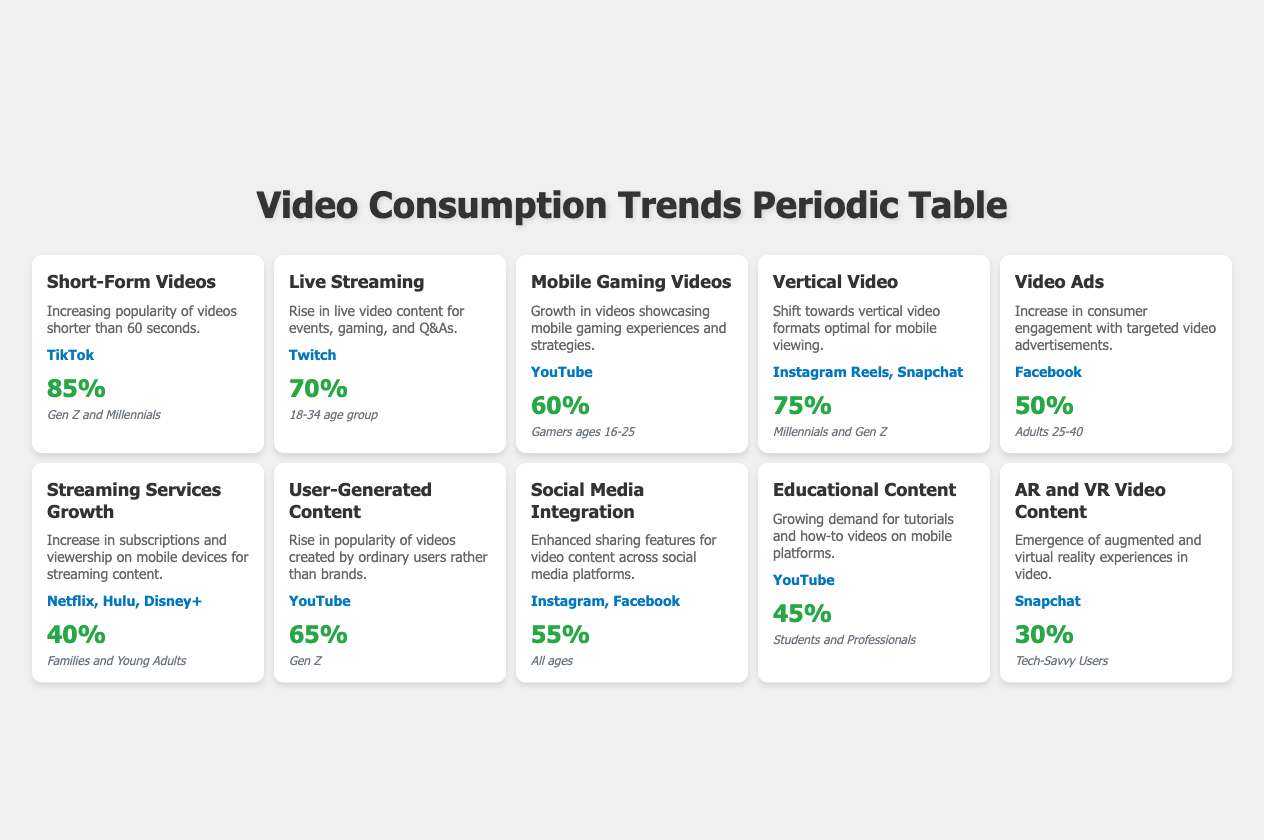What is the growth rate of Short-Form Videos? The table shows the specific growth rate for Short-Form Videos listed under the "GrowthRate" column. It states "85%" for this trend.
Answer: 85% Which platforms are associated with Vertical Video? Looking at the table, the platforms listed for Vertical Video are under the "Platforms" column. It mentions "Instagram Reels, Snapchat."
Answer: Instagram Reels, Snapchat What percentage growth rate do Video Ads have compared to Live Streaming? The growth rate for Video Ads is "50%" and for Live Streaming is "70%." To find the difference, subtract 50% from 70%, which equals 20%.
Answer: 20% Is the demographic for Mobile Gaming Videos specifically targeted towards Gen Z? The demographic for Mobile Gaming Videos, according to the table, is "Gamers ages 16-25," which includes Gen Z but does not specifically target only them. Therefore, the answer is no.
Answer: No What is the average growth rate of all video consumption trends listed in the table? To calculate the average growth rate, add all growth rates: 85% + 70% + 60% + 75% + 50% + 40% + 65% + 55% + 45% + 30% = 675%. There are 10 trends, so divide 675% by 10, resulting in an average of 67.5%.
Answer: 67.5% Does Social Media Integration have a higher growth rate than Educational Content? The growth rate for Social Media Integration is "55%" and for Educational Content is "45%." Since 55% is greater than 45%, the answer is yes.
Answer: Yes Which trend has the highest growth rate based on the table? By reviewing the "GrowthRate" column, Short-Form Videos have the highest growth rate of "85%."
Answer: Short-Form Videos Is AR and VR Video Content gaining popularity more than Streaming Services Growth? The growth rate for AR and VR Video Content is "30%" and for Streaming Services Growth is "40%." Since 30% is less than 40%, the answer is no.
Answer: No What demographic is associated with User-Generated Content? Looking at the table, the demographic listed for User-Generated Content is "Gen Z."
Answer: Gen Z What growth trend shows the largest audience age range? The Streaming Services Growth trend targets "Families and Young Adults," which encompasses multiple age groups, making it the trend with the largest audience.
Answer: Streaming Services Growth 